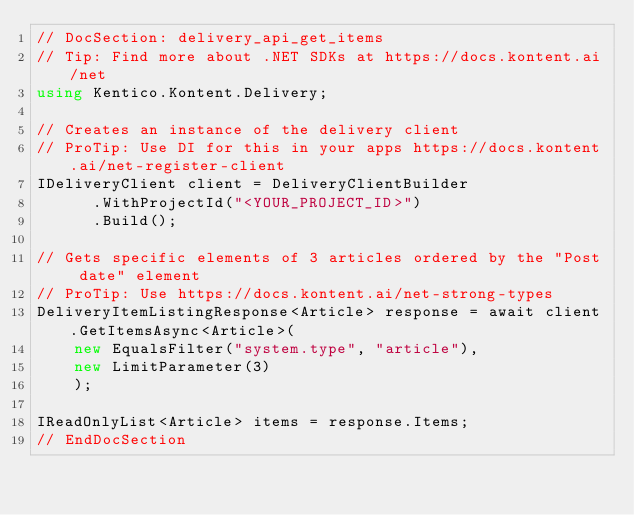<code> <loc_0><loc_0><loc_500><loc_500><_C#_>// DocSection: delivery_api_get_items
// Tip: Find more about .NET SDKs at https://docs.kontent.ai/net
using Kentico.Kontent.Delivery;

// Creates an instance of the delivery client
// ProTip: Use DI for this in your apps https://docs.kontent.ai/net-register-client
IDeliveryClient client = DeliveryClientBuilder
      .WithProjectId("<YOUR_PROJECT_ID>")
      .Build();

// Gets specific elements of 3 articles ordered by the "Post date" element
// ProTip: Use https://docs.kontent.ai/net-strong-types
DeliveryItemListingResponse<Article> response = await client.GetItemsAsync<Article>(
    new EqualsFilter("system.type", "article"),
    new LimitParameter(3)
    );

IReadOnlyList<Article> items = response.Items;
// EndDocSection</code> 